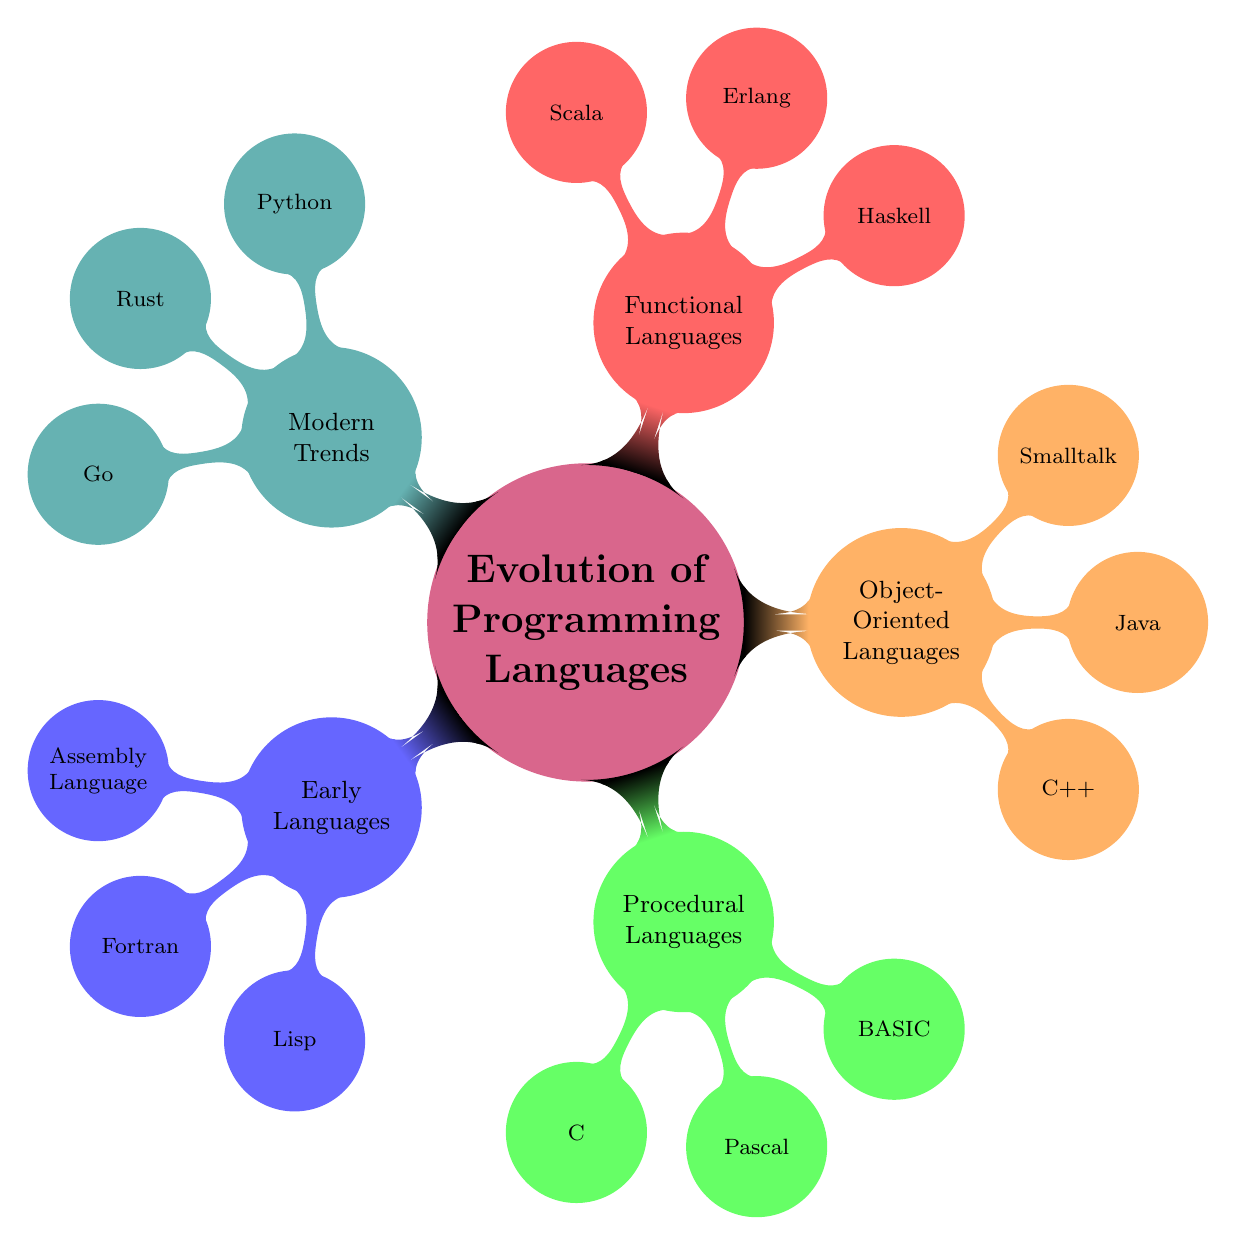What are the main categories of programming languages represented in the diagram? The diagram includes five main categories: Early Languages, Procedural Languages, Object-Oriented Languages, Functional Languages, and Modern Trends.
Answer: Early Languages, Procedural Languages, Object-Oriented Languages, Functional Languages, Modern Trends How many languages are listed under Object-Oriented Languages? There are three languages listed under Object-Oriented Languages: C++, Java, and Smalltalk.
Answer: 3 Which language is associated with functional programming paradigms in the diagram? The diagram lists three languages under Functional Languages: Haskell, Erlang, and Scala. Any of these can represent functional programming, but they are all categorized together, indicating their association with functional paradigms.
Answer: Haskell, Erlang, Scala What is the relationship between Procedural Languages and Object-Oriented Languages in the diagram? Procedural Languages and Object-Oriented Languages are two different categories within the main topic of the Evolution of Programming Languages. Each of them has its own distinct languages that fall under their respective categories, showing a progression in programming paradigms.
Answer: Different categories Which language is listed as a modern trend and is designed for system programming? Rust is noted as a modern trend in the diagram, and it is specifically designed for system programming purposes.
Answer: Rust How many total programming languages are mentioned in the diagram? By counting all languages from each category: Early Languages (3), Procedural Languages (3), Object-Oriented Languages (3), Functional Languages (3), and Modern Trends (3), we find there are a total of 15 programming languages mentioned.
Answer: 15 